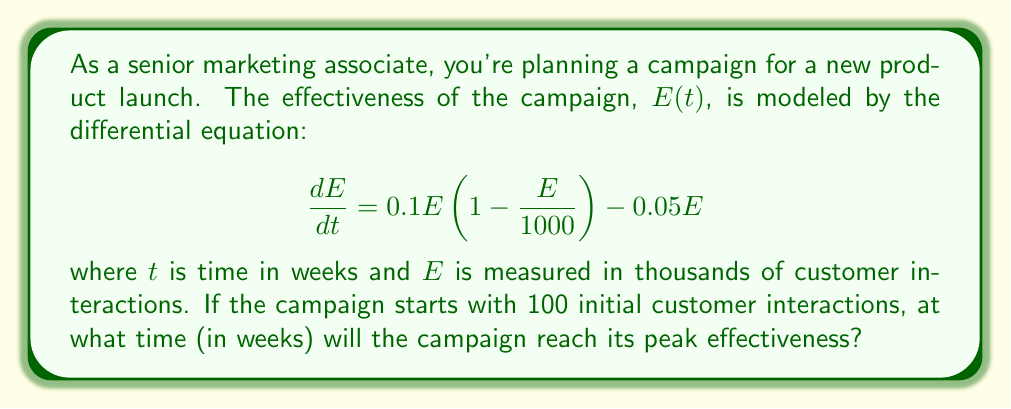Teach me how to tackle this problem. To solve this problem, we'll follow these steps:

1) First, we need to find the equilibrium points of the system. These occur when $\frac{dE}{dt} = 0$:

   $$0.1E(1 - \frac{E}{1000}) - 0.05E = 0$$

2) Factoring out $E$:

   $$E(0.1 - \frac{0.1E}{1000} - 0.05) = 0$$

3) Solving this equation:
   
   $E = 0$ or $0.1 - \frac{0.1E}{1000} - 0.05 = 0$
   
   From the second equation:
   $0.05 = \frac{0.1E}{1000}$
   $E = 500$

4) So, the equilibrium points are $E = 0$ and $E = 500$.

5) The campaign starts at $E = 100$ and will reach its peak at $E = 500$.

6) To find the time to reach this peak, we need to solve the differential equation:

   $$\frac{dE}{dt} = 0.1E(1 - \frac{E}{1000}) - 0.05E = 0.05E(1 - \frac{E}{500})$$

7) This is a logistic equation. Its solution is:

   $$E(t) = \frac{500}{1 + (\frac{500}{E_0} - 1)e^{-0.05t}}$$

   where $E_0 = 100$ is the initial value.

8) We want to find $t$ when $E(t) = 500$. Substituting:

   $$500 = \frac{500}{1 + (\frac{500}{100} - 1)e^{-0.05t}}$$

9) Simplifying:

   $$1 = \frac{1}{1 + 4e^{-0.05t}}$$
   $$4e^{-0.05t} = 0$$

10) This is true as $t$ approaches infinity. In practice, we can consider the peak reached when $E$ is very close to 500, say 99% of 500.

11) Solving for 99% of the peak:

    $$495 = \frac{500}{1 + 4e^{-0.05t}}$$
    $$0.01 = 4e^{-0.05t}$$
    $$\ln(0.0025) = -0.05t$$
    $$t = \frac{\ln(0.0025)}{-0.05} \approx 73.8$$

Therefore, the campaign will reach its peak effectiveness after approximately 74 weeks.
Answer: 74 weeks 